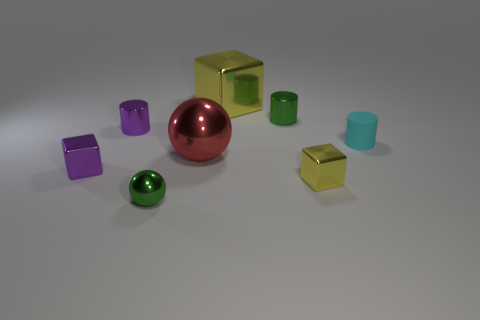Add 2 purple metal blocks. How many objects exist? 10 Subtract all balls. How many objects are left? 6 Subtract all small rubber cylinders. Subtract all small purple objects. How many objects are left? 5 Add 4 big yellow objects. How many big yellow objects are left? 5 Add 2 small rubber cylinders. How many small rubber cylinders exist? 3 Subtract 0 brown cylinders. How many objects are left? 8 